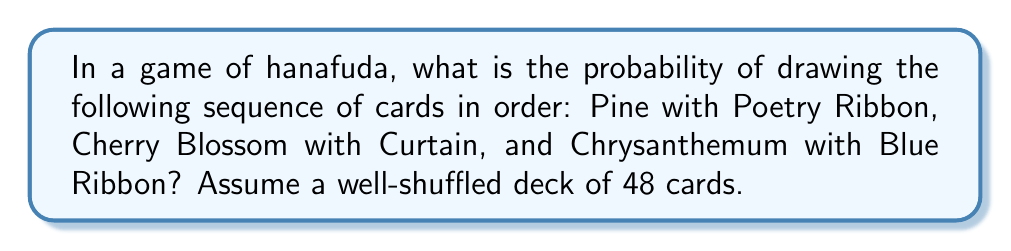Give your solution to this math problem. Let's approach this step-by-step:

1) In a hanafuda deck, there are 48 cards in total.

2) For each of the specified cards:
   - There is only 1 Pine with Poetry Ribbon
   - There is only 1 Cherry Blossom with Curtain
   - There is only 1 Chrysanthemum with Blue Ribbon

3) To calculate the probability of drawing these cards in this specific order:

   a) Probability of drawing Pine with Poetry Ribbon first:
      $P(\text{Pine}) = \frac{1}{48}$

   b) After drawing the first card, there are 47 cards left. Probability of drawing Cherry Blossom with Curtain second:
      $P(\text{Cherry}|\text{Pine}) = \frac{1}{47}$

   c) After drawing the second card, there are 46 cards left. Probability of drawing Chrysanthemum with Blue Ribbon third:
      $P(\text{Chrysanthemum}|\text{Pine, Cherry}) = \frac{1}{46}$

4) The probability of all these events occurring in this specific order is the product of their individual probabilities:

   $$P(\text{Pine, Cherry, Chrysanthemum in order}) = \frac{1}{48} \times \frac{1}{47} \times \frac{1}{46}$$

5) Calculating this:
   $$\frac{1}{48 \times 47 \times 46} = \frac{1}{103,776} \approx 0.0000096359$$

Therefore, the probability of drawing these specific cards in this exact order is 1 in 103,776.
Answer: $\frac{1}{103,776}$ 